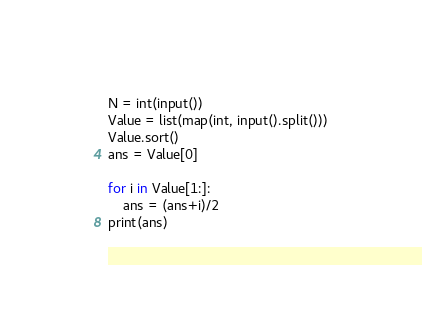Convert code to text. <code><loc_0><loc_0><loc_500><loc_500><_Python_>N = int(input())
Value = list(map(int, input().split()))
Value.sort()
ans = Value[0]

for i in Value[1:]:
    ans = (ans+i)/2
print(ans)</code> 